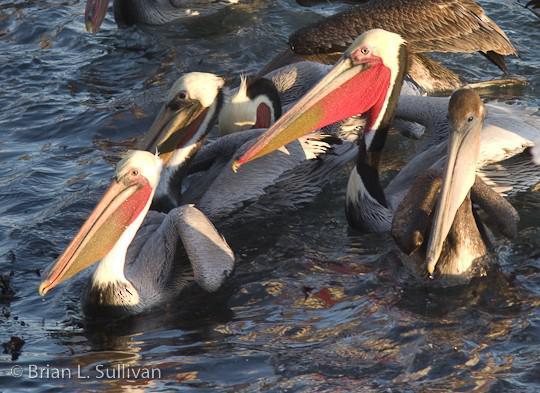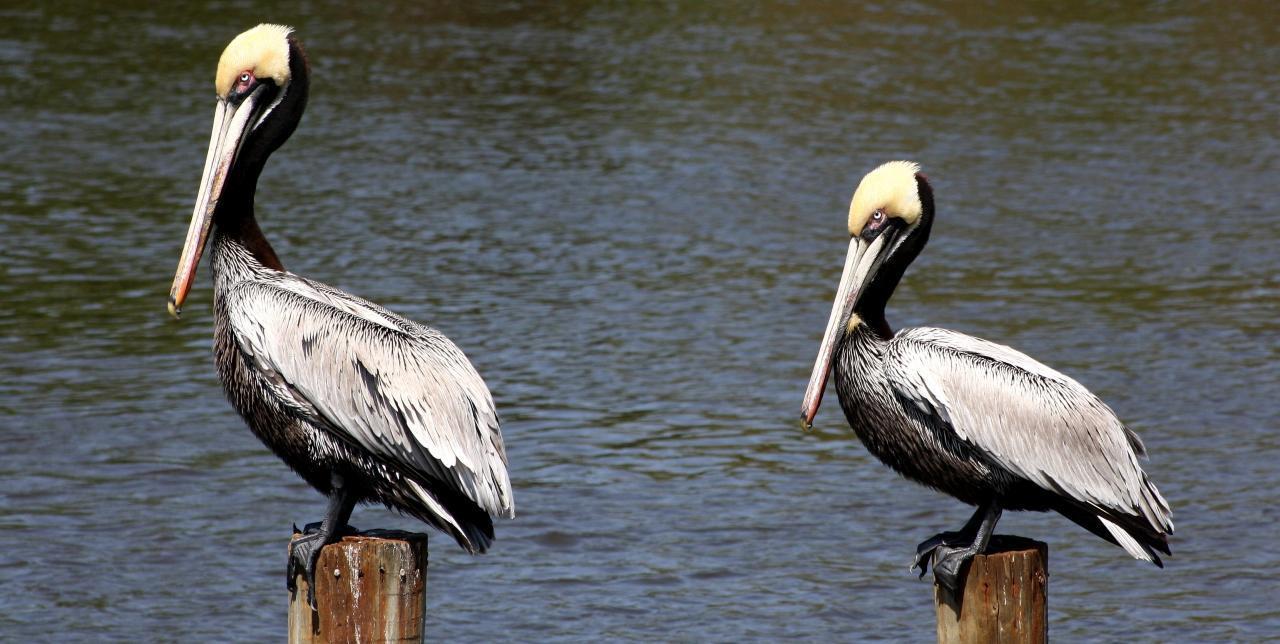The first image is the image on the left, the second image is the image on the right. Evaluate the accuracy of this statement regarding the images: "there are no more then two birds in the left pic". Is it true? Answer yes or no. No. The first image is the image on the left, the second image is the image on the right. For the images displayed, is the sentence "There are at least six pelicans." factually correct? Answer yes or no. Yes. 